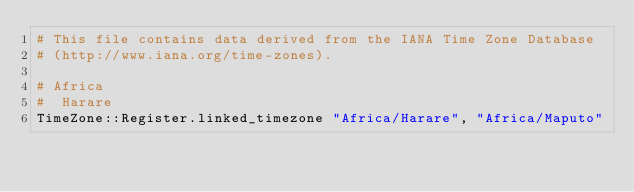Convert code to text. <code><loc_0><loc_0><loc_500><loc_500><_Crystal_># This file contains data derived from the IANA Time Zone Database
# (http://www.iana.org/time-zones).

# Africa
#  Harare
TimeZone::Register.linked_timezone "Africa/Harare", "Africa/Maputo"
</code> 